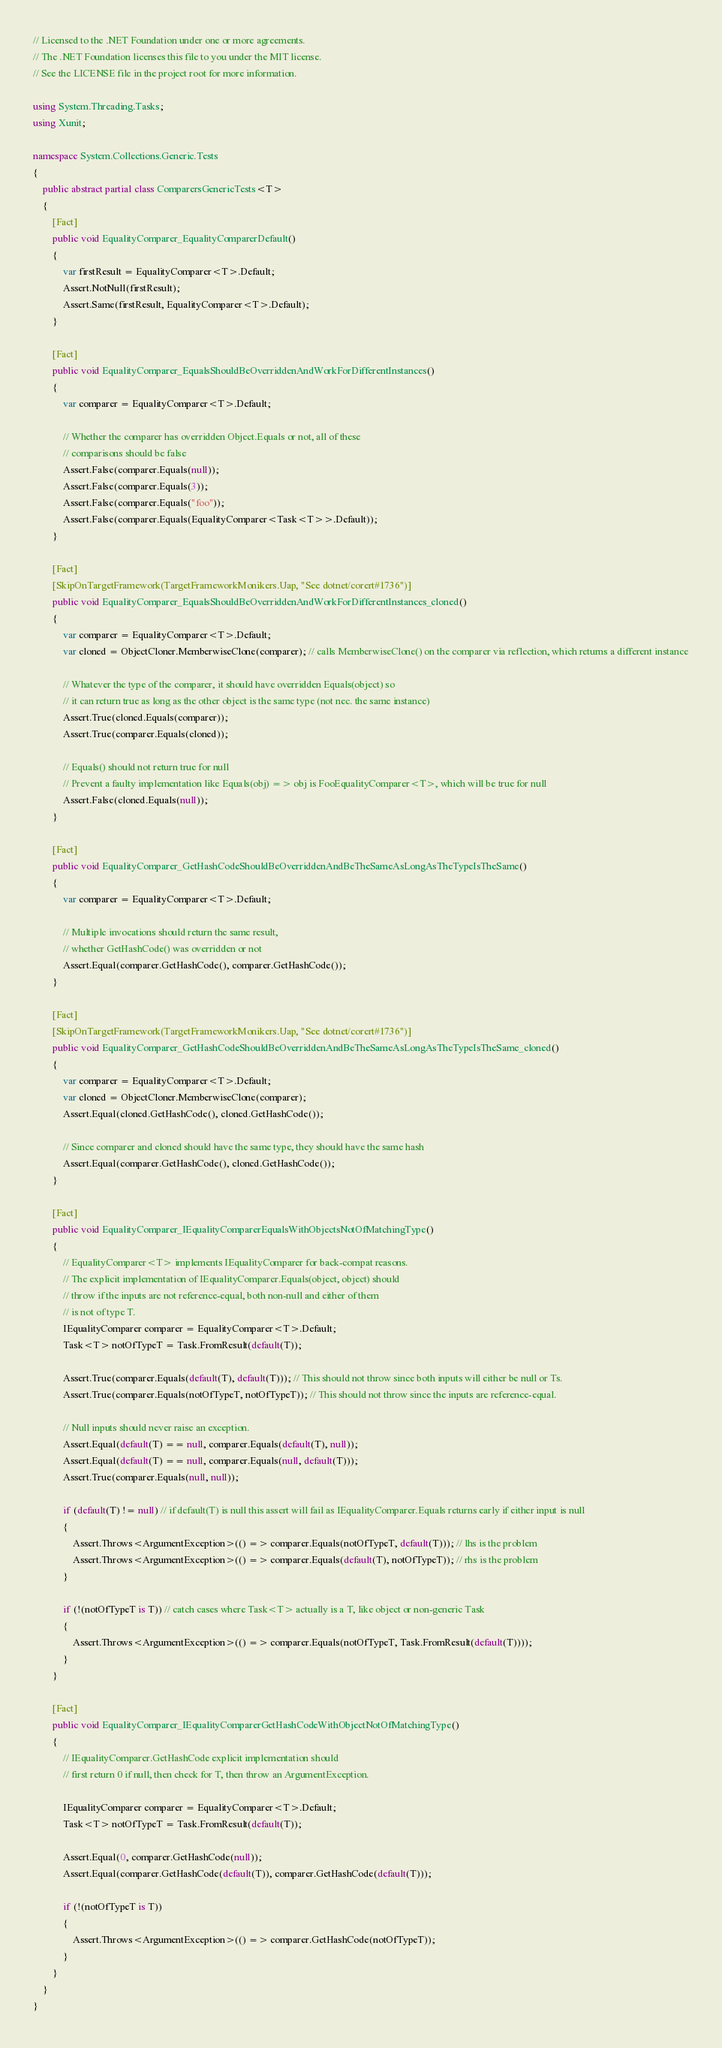<code> <loc_0><loc_0><loc_500><loc_500><_C#_>// Licensed to the .NET Foundation under one or more agreements.
// The .NET Foundation licenses this file to you under the MIT license.
// See the LICENSE file in the project root for more information.

using System.Threading.Tasks;
using Xunit;

namespace System.Collections.Generic.Tests
{
    public abstract partial class ComparersGenericTests<T>
    {
        [Fact]
        public void EqualityComparer_EqualityComparerDefault()
        {
            var firstResult = EqualityComparer<T>.Default;
            Assert.NotNull(firstResult);
            Assert.Same(firstResult, EqualityComparer<T>.Default);
        }

        [Fact]
        public void EqualityComparer_EqualsShouldBeOverriddenAndWorkForDifferentInstances()
        {
            var comparer = EqualityComparer<T>.Default;

            // Whether the comparer has overridden Object.Equals or not, all of these
            // comparisons should be false
            Assert.False(comparer.Equals(null));
            Assert.False(comparer.Equals(3));
            Assert.False(comparer.Equals("foo"));
            Assert.False(comparer.Equals(EqualityComparer<Task<T>>.Default));
        }

        [Fact]
        [SkipOnTargetFramework(TargetFrameworkMonikers.Uap, "See dotnet/corert#1736")]
        public void EqualityComparer_EqualsShouldBeOverriddenAndWorkForDifferentInstances_cloned()
        {
            var comparer = EqualityComparer<T>.Default;
            var cloned = ObjectCloner.MemberwiseClone(comparer); // calls MemberwiseClone() on the comparer via reflection, which returns a different instance

            // Whatever the type of the comparer, it should have overridden Equals(object) so
            // it can return true as long as the other object is the same type (not nec. the same instance)
            Assert.True(cloned.Equals(comparer));
            Assert.True(comparer.Equals(cloned));

            // Equals() should not return true for null
            // Prevent a faulty implementation like Equals(obj) => obj is FooEqualityComparer<T>, which will be true for null
            Assert.False(cloned.Equals(null));
        }

        [Fact]
        public void EqualityComparer_GetHashCodeShouldBeOverriddenAndBeTheSameAsLongAsTheTypeIsTheSame()
        {
            var comparer = EqualityComparer<T>.Default;

            // Multiple invocations should return the same result,
            // whether GetHashCode() was overridden or not
            Assert.Equal(comparer.GetHashCode(), comparer.GetHashCode());
        }

        [Fact]
        [SkipOnTargetFramework(TargetFrameworkMonikers.Uap, "See dotnet/corert#1736")]
        public void EqualityComparer_GetHashCodeShouldBeOverriddenAndBeTheSameAsLongAsTheTypeIsTheSame_cloned()
        {
            var comparer = EqualityComparer<T>.Default;
            var cloned = ObjectCloner.MemberwiseClone(comparer);
            Assert.Equal(cloned.GetHashCode(), cloned.GetHashCode());

            // Since comparer and cloned should have the same type, they should have the same hash
            Assert.Equal(comparer.GetHashCode(), cloned.GetHashCode());
        }

        [Fact]
        public void EqualityComparer_IEqualityComparerEqualsWithObjectsNotOfMatchingType()
        {
            // EqualityComparer<T> implements IEqualityComparer for back-compat reasons.
            // The explicit implementation of IEqualityComparer.Equals(object, object) should
            // throw if the inputs are not reference-equal, both non-null and either of them
            // is not of type T.
            IEqualityComparer comparer = EqualityComparer<T>.Default;
            Task<T> notOfTypeT = Task.FromResult(default(T));

            Assert.True(comparer.Equals(default(T), default(T))); // This should not throw since both inputs will either be null or Ts.
            Assert.True(comparer.Equals(notOfTypeT, notOfTypeT)); // This should not throw since the inputs are reference-equal.

            // Null inputs should never raise an exception.
            Assert.Equal(default(T) == null, comparer.Equals(default(T), null));
            Assert.Equal(default(T) == null, comparer.Equals(null, default(T)));
            Assert.True(comparer.Equals(null, null));

            if (default(T) != null) // if default(T) is null this assert will fail as IEqualityComparer.Equals returns early if either input is null
            {
                Assert.Throws<ArgumentException>(() => comparer.Equals(notOfTypeT, default(T))); // lhs is the problem
                Assert.Throws<ArgumentException>(() => comparer.Equals(default(T), notOfTypeT)); // rhs is the problem
            }

            if (!(notOfTypeT is T)) // catch cases where Task<T> actually is a T, like object or non-generic Task
            {
                Assert.Throws<ArgumentException>(() => comparer.Equals(notOfTypeT, Task.FromResult(default(T))));
            }
        }

        [Fact]
        public void EqualityComparer_IEqualityComparerGetHashCodeWithObjectNotOfMatchingType()
        {
            // IEqualityComparer.GetHashCode explicit implementation should
            // first return 0 if null, then check for T, then throw an ArgumentException.

            IEqualityComparer comparer = EqualityComparer<T>.Default;
            Task<T> notOfTypeT = Task.FromResult(default(T));

            Assert.Equal(0, comparer.GetHashCode(null));
            Assert.Equal(comparer.GetHashCode(default(T)), comparer.GetHashCode(default(T)));

            if (!(notOfTypeT is T))
            {
                Assert.Throws<ArgumentException>(() => comparer.GetHashCode(notOfTypeT));
            }
        }
    }
}
</code> 